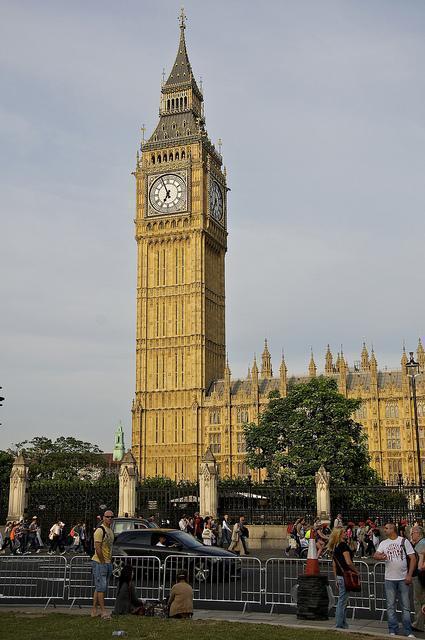How many people are there?
Give a very brief answer. 2. How many horses are grazing on the hill?
Give a very brief answer. 0. 